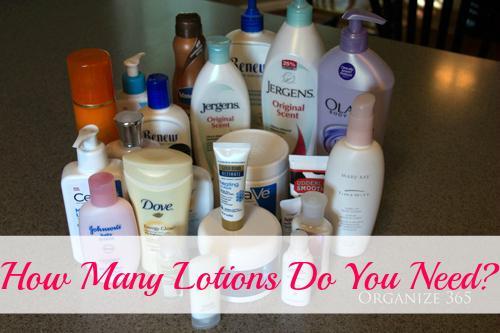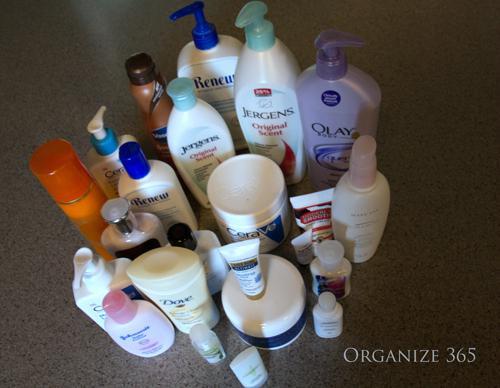The first image is the image on the left, the second image is the image on the right. For the images displayed, is the sentence "An image shows one black shelf holding a row of six beauty products." factually correct? Answer yes or no. No. 